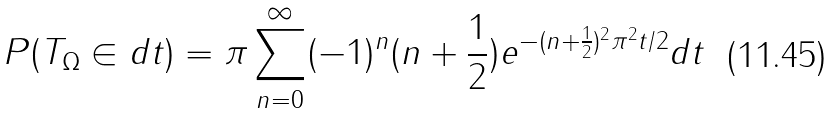Convert formula to latex. <formula><loc_0><loc_0><loc_500><loc_500>P ( T _ { \Omega } \in d t ) = \pi \sum _ { n = 0 } ^ { \infty } ( - 1 ) ^ { n } ( n + \frac { 1 } { 2 } ) e ^ { - ( n + \frac { 1 } { 2 } ) ^ { 2 } \pi ^ { 2 } t / 2 } d t</formula> 